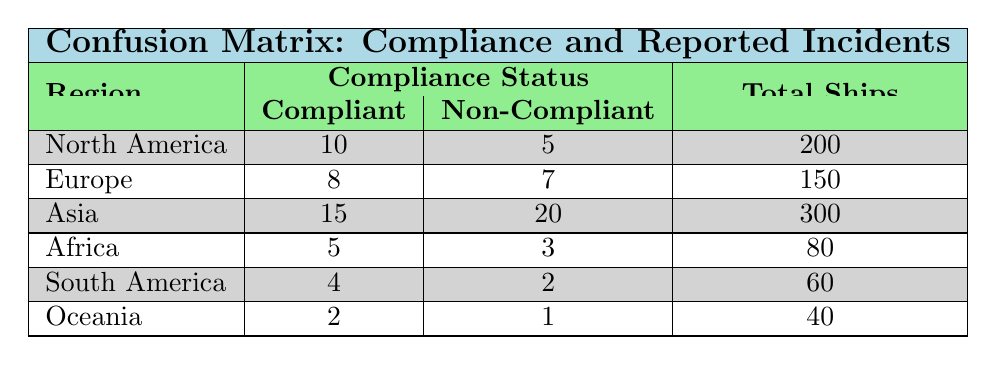What is the total number of ships reported in North America? In the table, North America has a total of 200 ships listed under its compliance status.
Answer: 200 How many reported incidents were there in Asia? For Asia, the table shows 15 reported incidents for compliant ships and 20 for non-compliant ships, thus the total is 15 + 20 = 35.
Answer: 35 Is Africa compliant with international shipping regulations? In the table, Africa has a compliant status with 5 reported incidents and non-compliant with 3 incidents, indicating that Africa does indeed have some compliant vessels.
Answer: Yes Which region has the highest number of reported incidents for non-compliant ships? Looking at the non-compliant column, Asia has 20 reported incidents, which is more than the other regions: North America (5), Europe (7), Africa (3), South America (2), and Oceania (1).
Answer: Asia What is the average number of reported incidents for compliant ships across all regions? The compliant ships reported incidents are: 10 (North America) + 8 (Europe) + 15 (Asia) + 5 (Africa) + 4 (South America) + 2 (Oceania) = 44 incidents. There are 6 regions, so the average is 44 / 6 = 7.33.
Answer: 7.33 How many total ships are compliant versus non-compliant in South America? In South America, there are 60 total ships, with 4 compliant and 2 non-compliant. The compliant ships are 4, and non-compliant are 2.
Answer: Compliant: 4, Non-Compliant: 2 Which region has the least total reported incidents? By examining the reported incidents: North America (15), Europe (15), Asia (35), Africa (8), South America (6), Oceania (3), it shows that Oceania has the least incidents with a total of 3 (1 non-compliant and 2 compliant).
Answer: Oceania If we combine the compliant ships in Europe and South America, what is their total? In Europe, there are 8 compliant ships, and in South America, there are 4 compliant ships. Adding these gives 8 + 4 = 12 compliant ships in total.
Answer: 12 What percentage of ships are compliant in North America? In North America, there are a total of 200 ships, with 10 compliant. The percentage is (10/200) * 100 = 5%.
Answer: 5% 